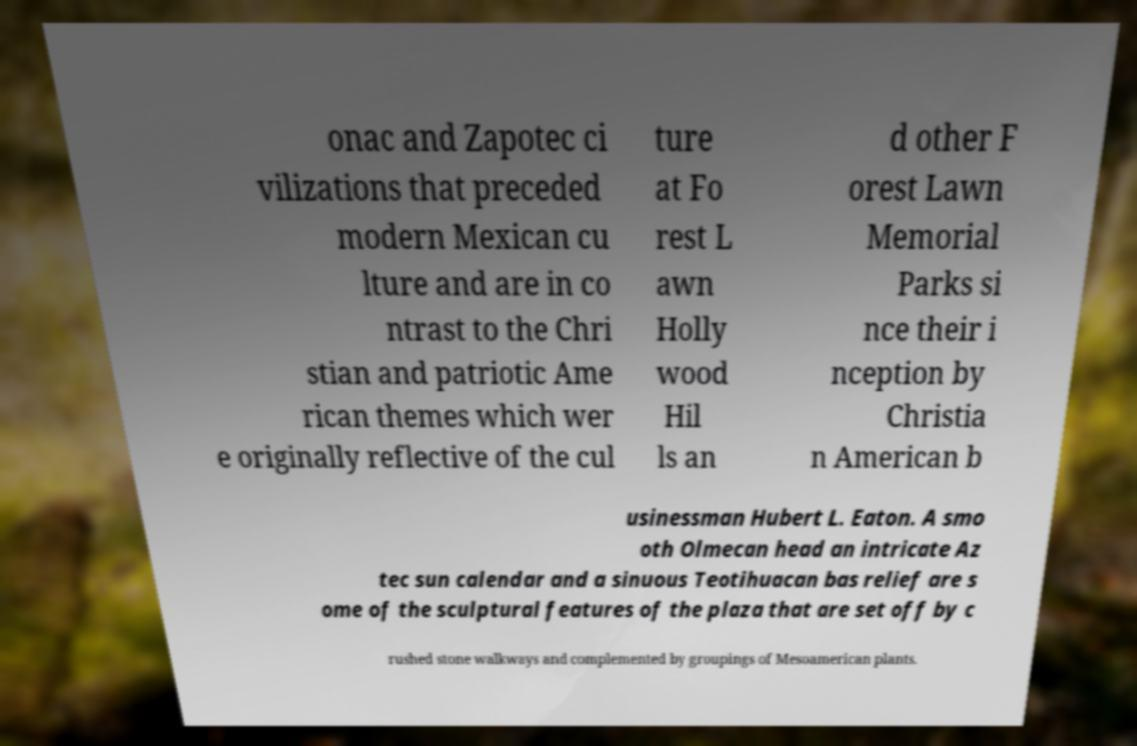Could you extract and type out the text from this image? onac and Zapotec ci vilizations that preceded modern Mexican cu lture and are in co ntrast to the Chri stian and patriotic Ame rican themes which wer e originally reflective of the cul ture at Fo rest L awn Holly wood Hil ls an d other F orest Lawn Memorial Parks si nce their i nception by Christia n American b usinessman Hubert L. Eaton. A smo oth Olmecan head an intricate Az tec sun calendar and a sinuous Teotihuacan bas relief are s ome of the sculptural features of the plaza that are set off by c rushed stone walkways and complemented by groupings of Mesoamerican plants. 